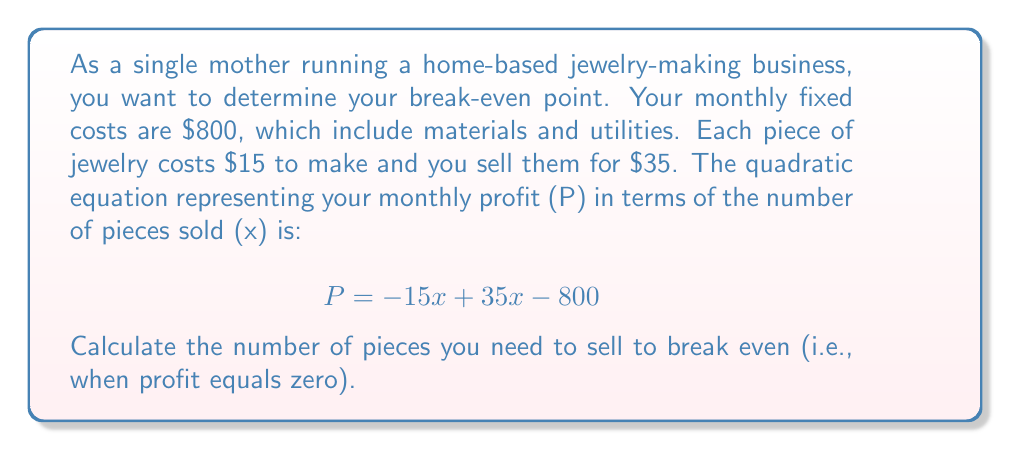What is the answer to this math problem? To find the break-even point, we need to solve the quadratic equation when P = 0:

$$ 0 = -15x + 35x - 800 $$

Simplify the equation:
$$ 0 = 20x - 800 $$

Add 800 to both sides:
$$ 800 = 20x $$

Divide both sides by 20:
$$ 40 = x $$

To verify, let's substitute x = 40 into the original equation:

$$ P = -15(40) + 35(40) - 800 $$
$$ P = -600 + 1400 - 800 $$
$$ P = 0 $$

This confirms that selling 40 pieces results in zero profit, which is the break-even point.
Answer: The break-even point is 40 pieces of jewelry. 